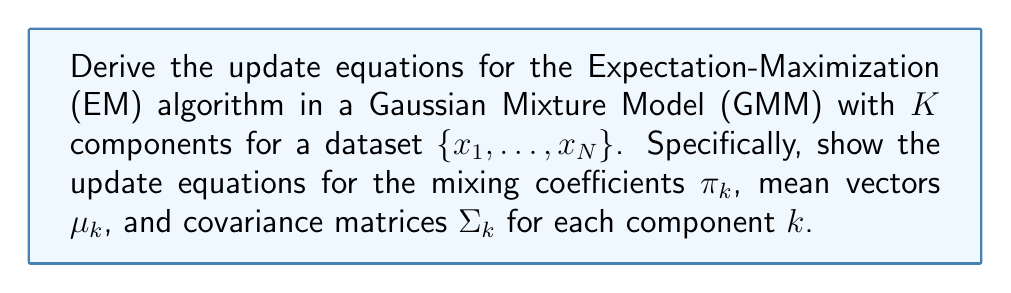Provide a solution to this math problem. To derive the update equations for the EM algorithm in Gaussian Mixture Models, we'll follow these steps:

1. Define the log-likelihood function
2. Introduce latent variables and define the complete-data log-likelihood
3. E-step: Compute the responsibilities
4. M-step: Maximize the expected complete-data log-likelihood

Step 1: Log-likelihood function

The log-likelihood function for a GMM is:

$$\ln p(X|\pi,\mu,\Sigma) = \sum_{n=1}^N \ln \left( \sum_{k=1}^K \pi_k \mathcal{N}(x_n|\mu_k,\Sigma_k) \right)$$

Step 2: Complete-data log-likelihood

Introduce latent variables $z_{nk}$ where $z_{nk}=1$ if $x_n$ belongs to component $k$, and 0 otherwise. The complete-data log-likelihood is:

$$\ln p(X,Z|\pi,\mu,\Sigma) = \sum_{n=1}^N \sum_{k=1}^K z_{nk} \left( \ln \pi_k + \ln \mathcal{N}(x_n|\mu_k,\Sigma_k) \right)$$

Step 3: E-step

Compute the responsibilities:

$$\gamma_{nk} = \frac{\pi_k \mathcal{N}(x_n|\mu_k,\Sigma_k)}{\sum_{j=1}^K \pi_j \mathcal{N}(x_n|\mu_j,\Sigma_j)}$$

Step 4: M-step

Maximize the expected complete-data log-likelihood with respect to the parameters:

a) Mixing coefficients:

$$\pi_k^{new} = \frac{1}{N} \sum_{n=1}^N \gamma_{nk}$$

b) Mean vectors:

$$\mu_k^{new} = \frac{\sum_{n=1}^N \gamma_{nk} x_n}{\sum_{n=1}^N \gamma_{nk}}$$

c) Covariance matrices:

$$\Sigma_k^{new} = \frac{\sum_{n=1}^N \gamma_{nk} (x_n - \mu_k^{new})(x_n - \mu_k^{new})^T}{\sum_{n=1}^N \gamma_{nk}}$$

These equations are derived by setting the derivatives of the expected complete-data log-likelihood with respect to each parameter to zero and solving for the parameter.
Answer: The update equations for the EM algorithm in Gaussian Mixture Models are:

1. Mixing coefficients: $\pi_k^{new} = \frac{1}{N} \sum_{n=1}^N \gamma_{nk}$

2. Mean vectors: $\mu_k^{new} = \frac{\sum_{n=1}^N \gamma_{nk} x_n}{\sum_{n=1}^N \gamma_{nk}}$

3. Covariance matrices: $\Sigma_k^{new} = \frac{\sum_{n=1}^N \gamma_{nk} (x_n - \mu_k^{new})(x_n - \mu_k^{new})^T}{\sum_{n=1}^N \gamma_{nk}}$

Where $\gamma_{nk}$ are the responsibilities computed in the E-step. 